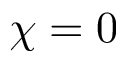Convert formula to latex. <formula><loc_0><loc_0><loc_500><loc_500>\chi = 0</formula> 